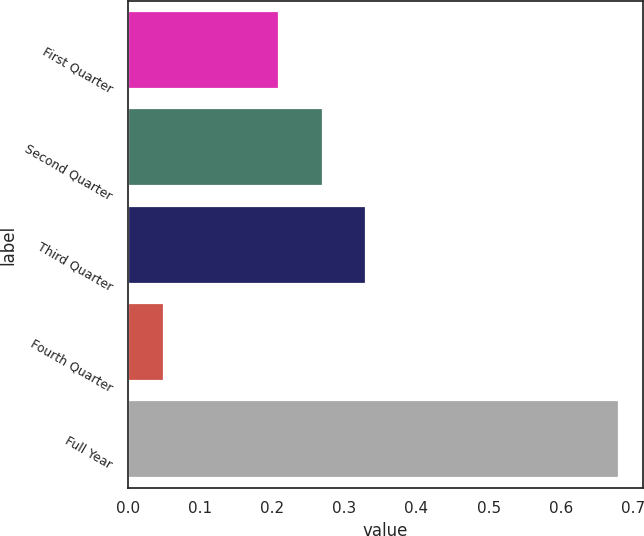Convert chart. <chart><loc_0><loc_0><loc_500><loc_500><bar_chart><fcel>First Quarter<fcel>Second Quarter<fcel>Third Quarter<fcel>Fourth Quarter<fcel>Full Year<nl><fcel>0.21<fcel>0.27<fcel>0.33<fcel>0.05<fcel>0.68<nl></chart> 